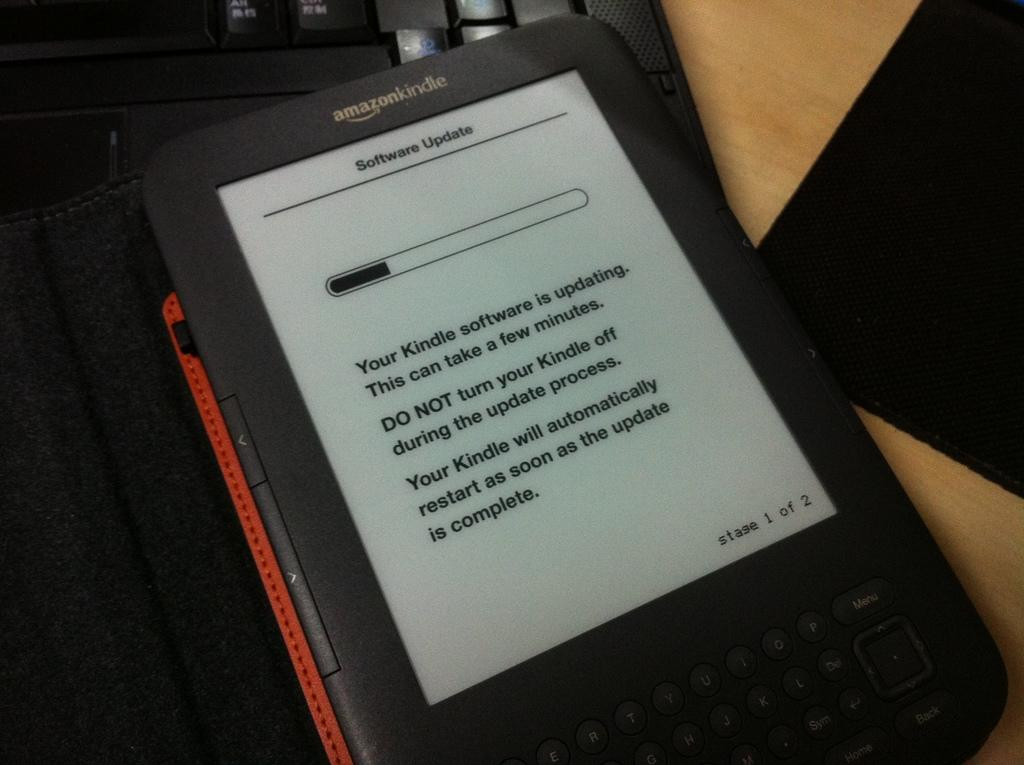What electronic device is visible in the image? There is a tablet in the image. What is placed on the wooden table in the image? There is a keyboard on the wooden table in the image. What type of corn is being grown in the image? There is no corn present in the image; it features a tablet and a keyboard on a wooden table. What breed of dog can be seen playing with the keyboard in the image? There is no dog present in the image; it only features a tablet and a keyboard on a wooden table. 